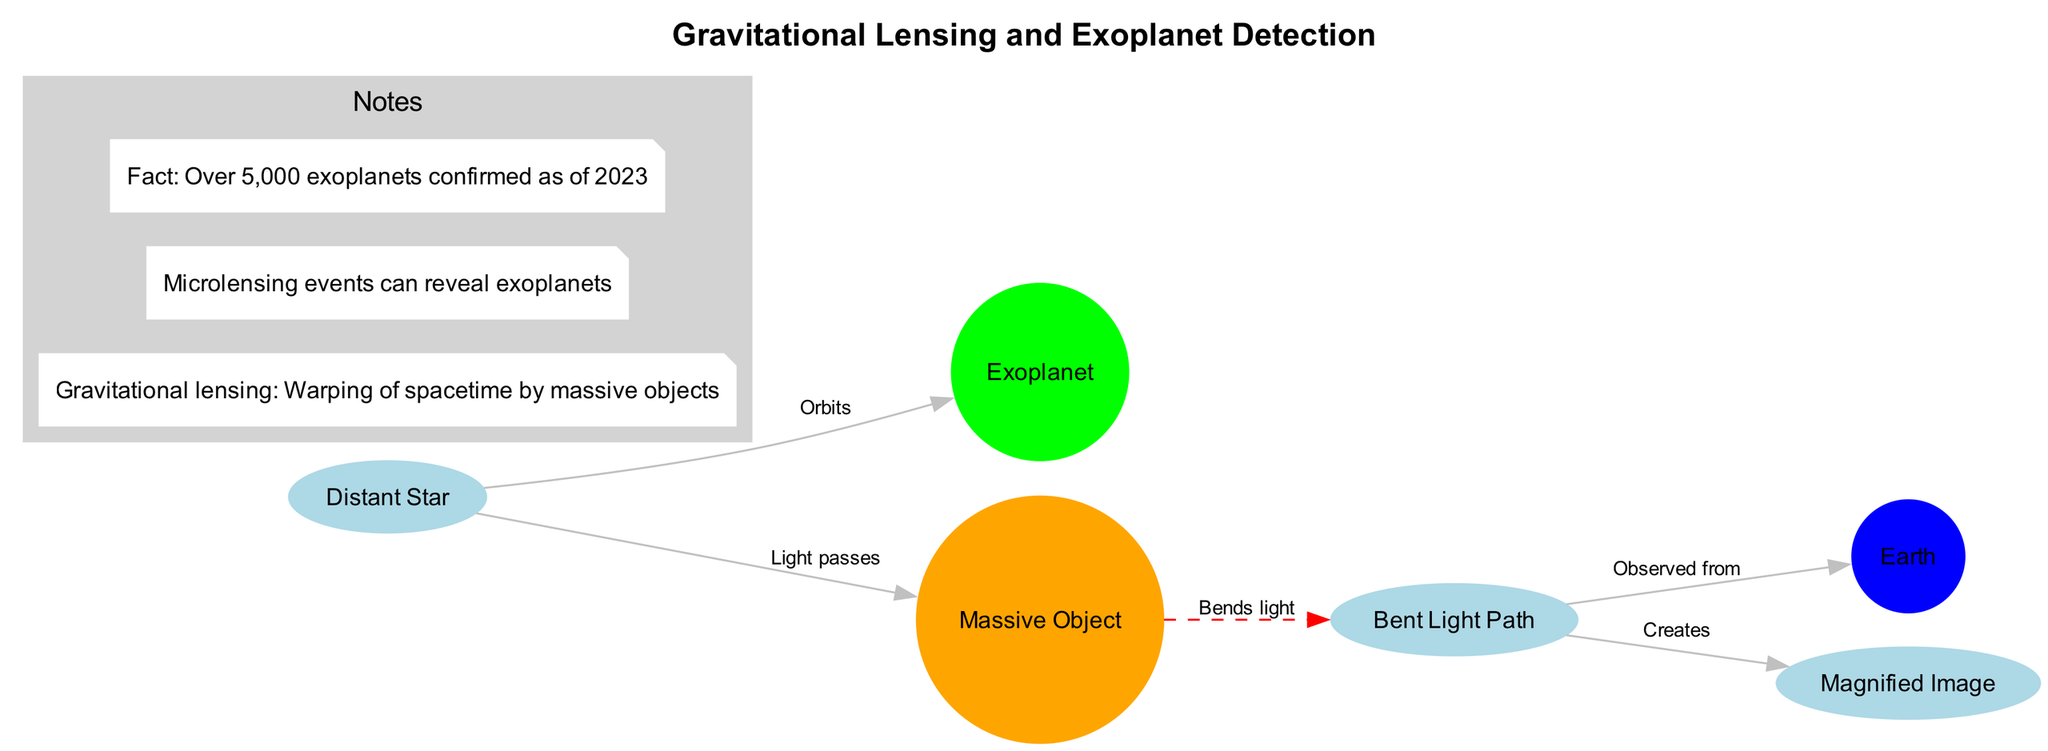What is the title of the diagram? The title of the diagram is located at the top of the graphic which summarizes its content. The title states "Gravitational Lensing and Exoplanet Detection."
Answer: Gravitational Lensing and Exoplanet Detection How many nodes are in the diagram? To find the number of nodes, we count the unique labeled elements in the diagram. There are six nodes: Distant Star, Exoplanet, Massive Object, Earth, Bent Light Path, and Magnified Image.
Answer: 6 What color represents the Massive Object in the diagram? The Massive Object is represented by a circle filled with orange color, which is visually distinct from the other nodes.
Answer: Orange Which node creates the Magnified Image? The edge labeled "Creates" points from the Bent Light Path to the Magnified Image. Therefore, the node that creates the Magnified Image is the Bent Light Path.
Answer: Bent Light Path What relationship does the Distant Star have with the Exoplanet? The relationship is represented by an edge labeled "Orbits," which indicates that the Exoplanet orbits the Distant Star.
Answer: Orbits How does the Massive Object affect the light from the Distant Star? According to the labeled edge "Bends light," the Massive Object bends the light path coming from the Distant Star due to gravitational lensing.
Answer: Bends light What is the significance of the microlensing events mentioned in the notes? The notes mention that microlensing events can reveal exoplanets, indicating that gravitational lensing can aid in the discovery of these distant worlds.
Answer: Reveal exoplanets From where is the light observed when it is bent? The edge labeled "Observed from" indicates that the bent light is observed from Earth. Thus, the source of observation is Earth.
Answer: Earth What is the main phenomenon illustrated in the diagram? The primary phenomenon illustrated is gravitational lensing, which describes the warping of spacetime around massive objects and its effects on light, aiding in the detection of exoplanets.
Answer: Gravitational lensing 